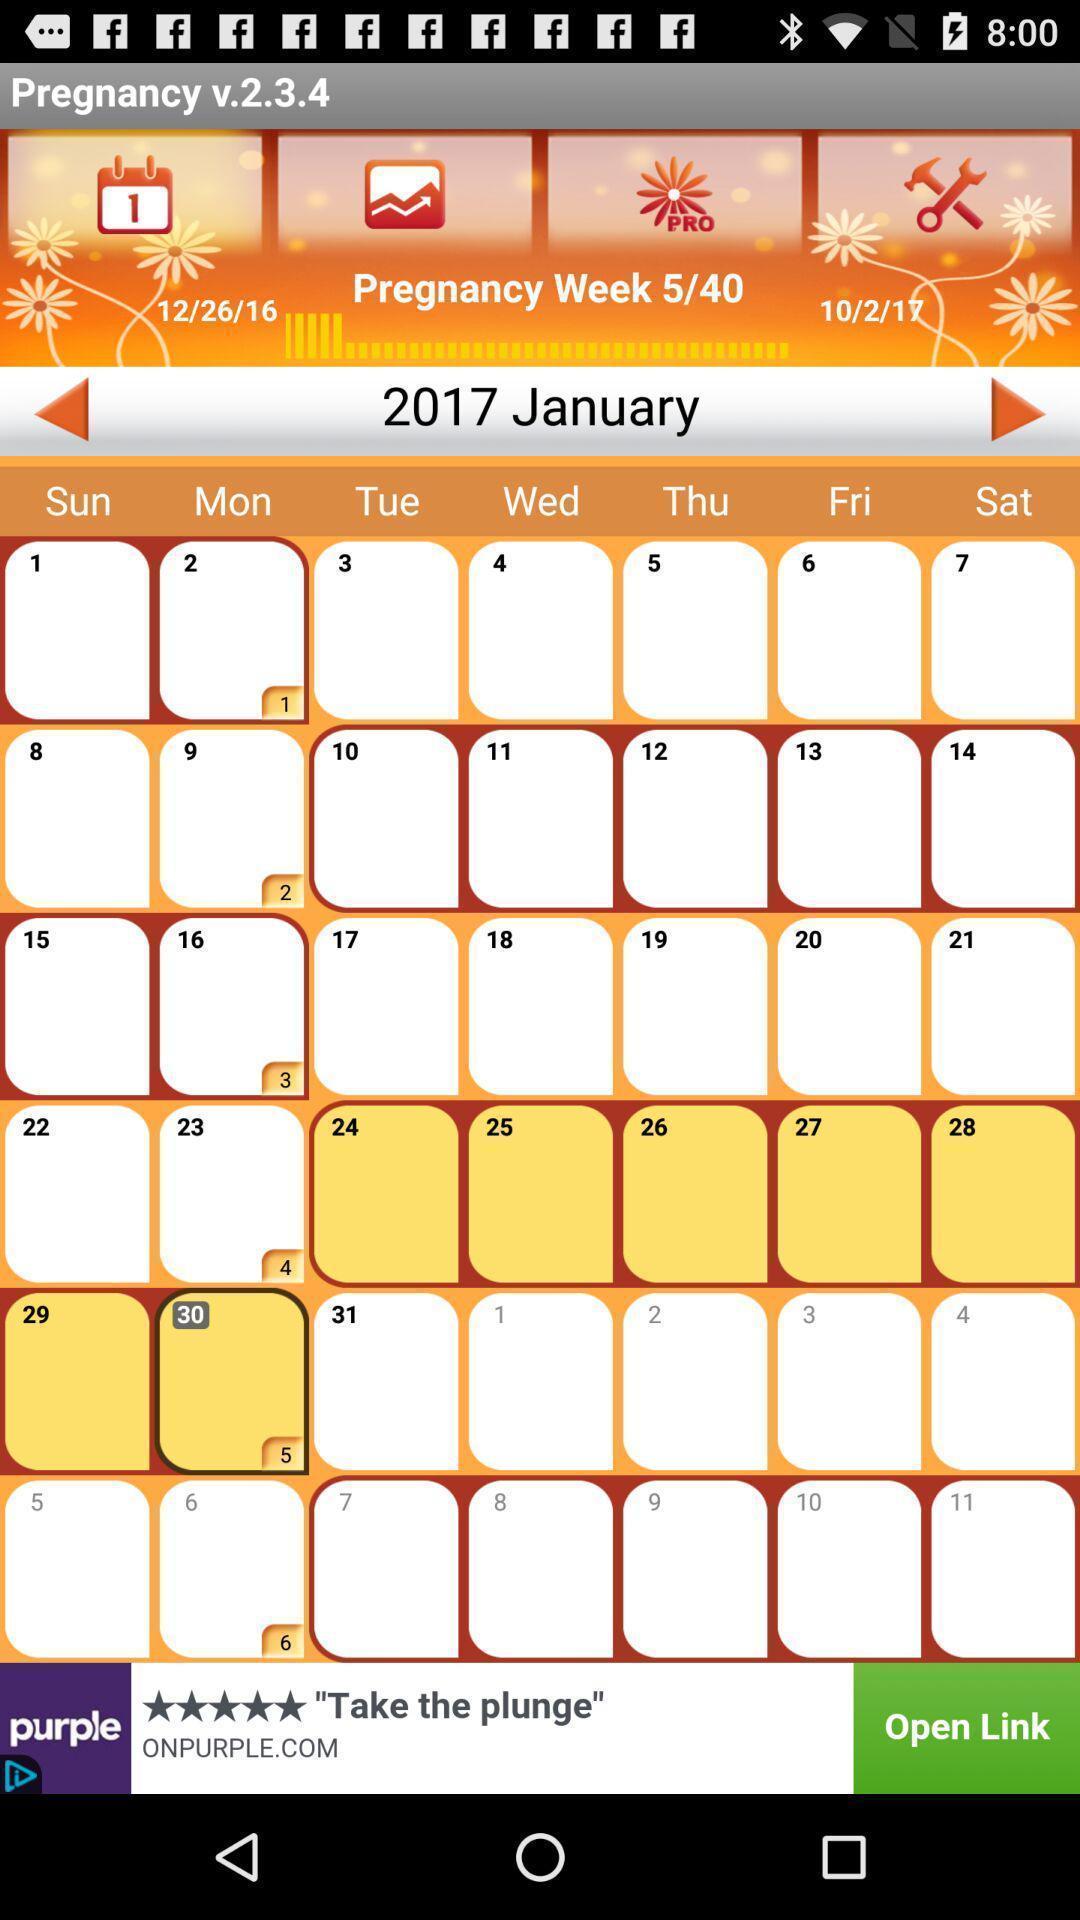Explain the elements present in this screenshot. Screen displaying the calendar of january month. 